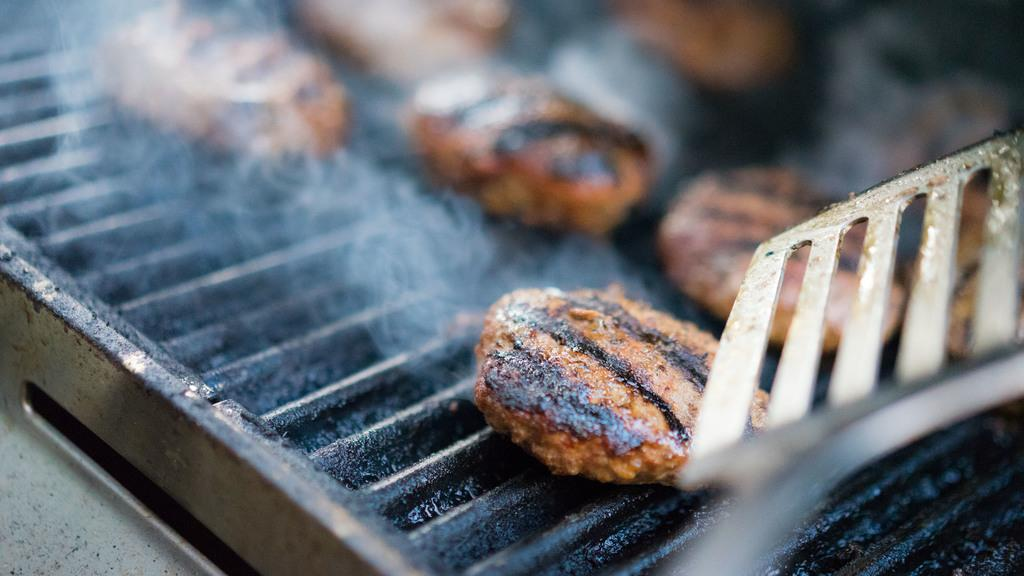What is being cooked on the grills in the image? There is a food item on grills in the image, but the specific type of food cannot be determined from the facts provided. What can be seen as a result of the cooking process in the image? There is smoke visible in the image. What type of circle is present in the image? There is no circle present in the image. How does the fog affect the visibility of the food item on the grills in the image? There is no fog present in the image. 